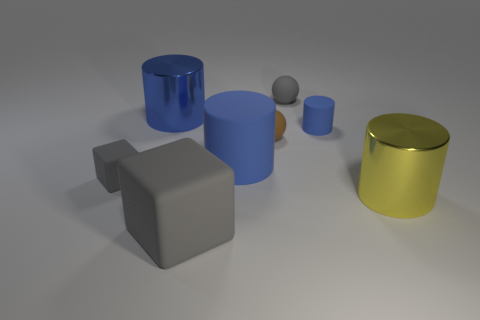The tiny block is what color?
Make the answer very short. Gray. What is the size of the shiny cylinder to the right of the gray rubber sphere?
Your response must be concise. Large. There is a large metal object in front of the shiny cylinder that is left of the tiny gray ball; how many matte cubes are behind it?
Keep it short and to the point. 1. What is the color of the shiny cylinder that is to the right of the small gray rubber thing right of the large blue shiny cylinder?
Provide a short and direct response. Yellow. Is there a purple thing of the same size as the yellow metallic cylinder?
Offer a very short reply. No. What material is the blue cylinder on the right side of the gray object that is right of the large thing that is in front of the large yellow metal thing?
Offer a very short reply. Rubber. There is a gray sphere that is on the left side of the yellow shiny cylinder; what number of large yellow shiny objects are to the right of it?
Offer a terse response. 1. Is the size of the shiny object to the left of the gray matte sphere the same as the small brown sphere?
Your response must be concise. No. How many tiny blue things have the same shape as the tiny brown matte thing?
Provide a short and direct response. 0. What is the shape of the brown object?
Make the answer very short. Sphere. 